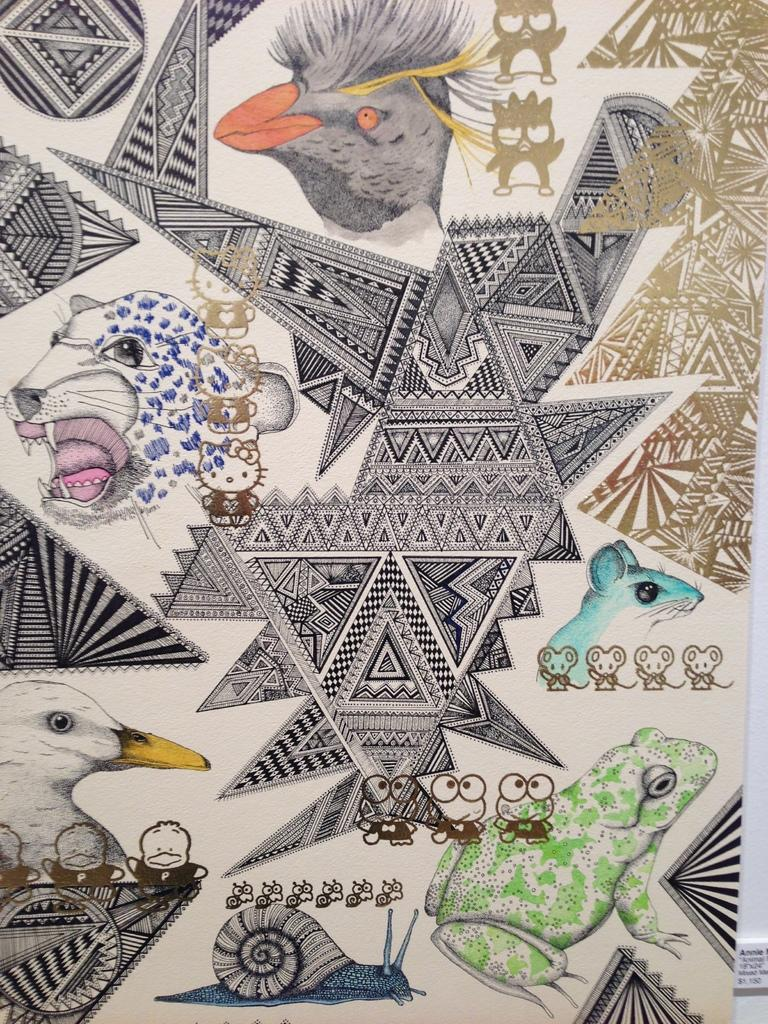What type of art is depicted in the image? The image is an asymmetric art. What can be seen in the sketches within the art? There are sketches of different animals in the image. What type of corn is being grown in the image? There is no corn present in the image; it features asymmetric art with sketches of different animals. 